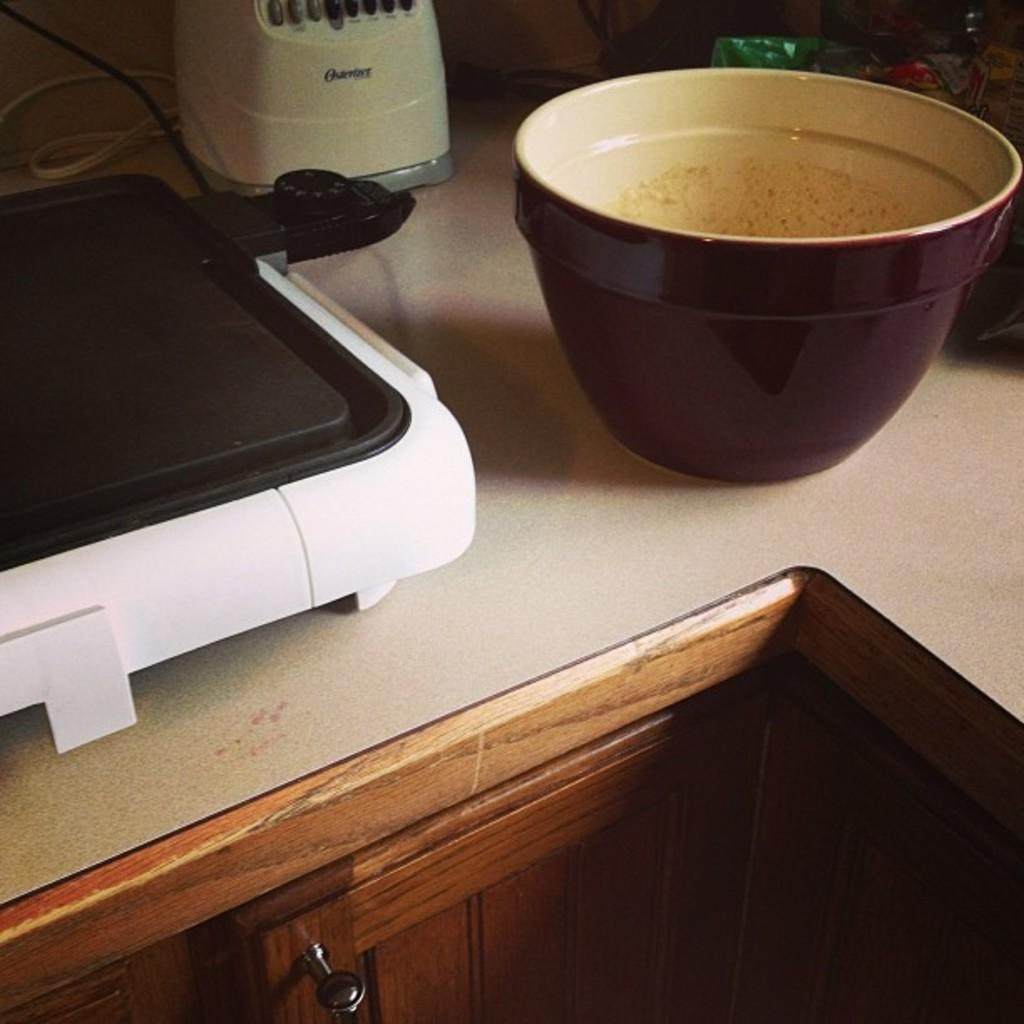<image>
Present a compact description of the photo's key features. An Oster brand blender is on a counter with other items. 